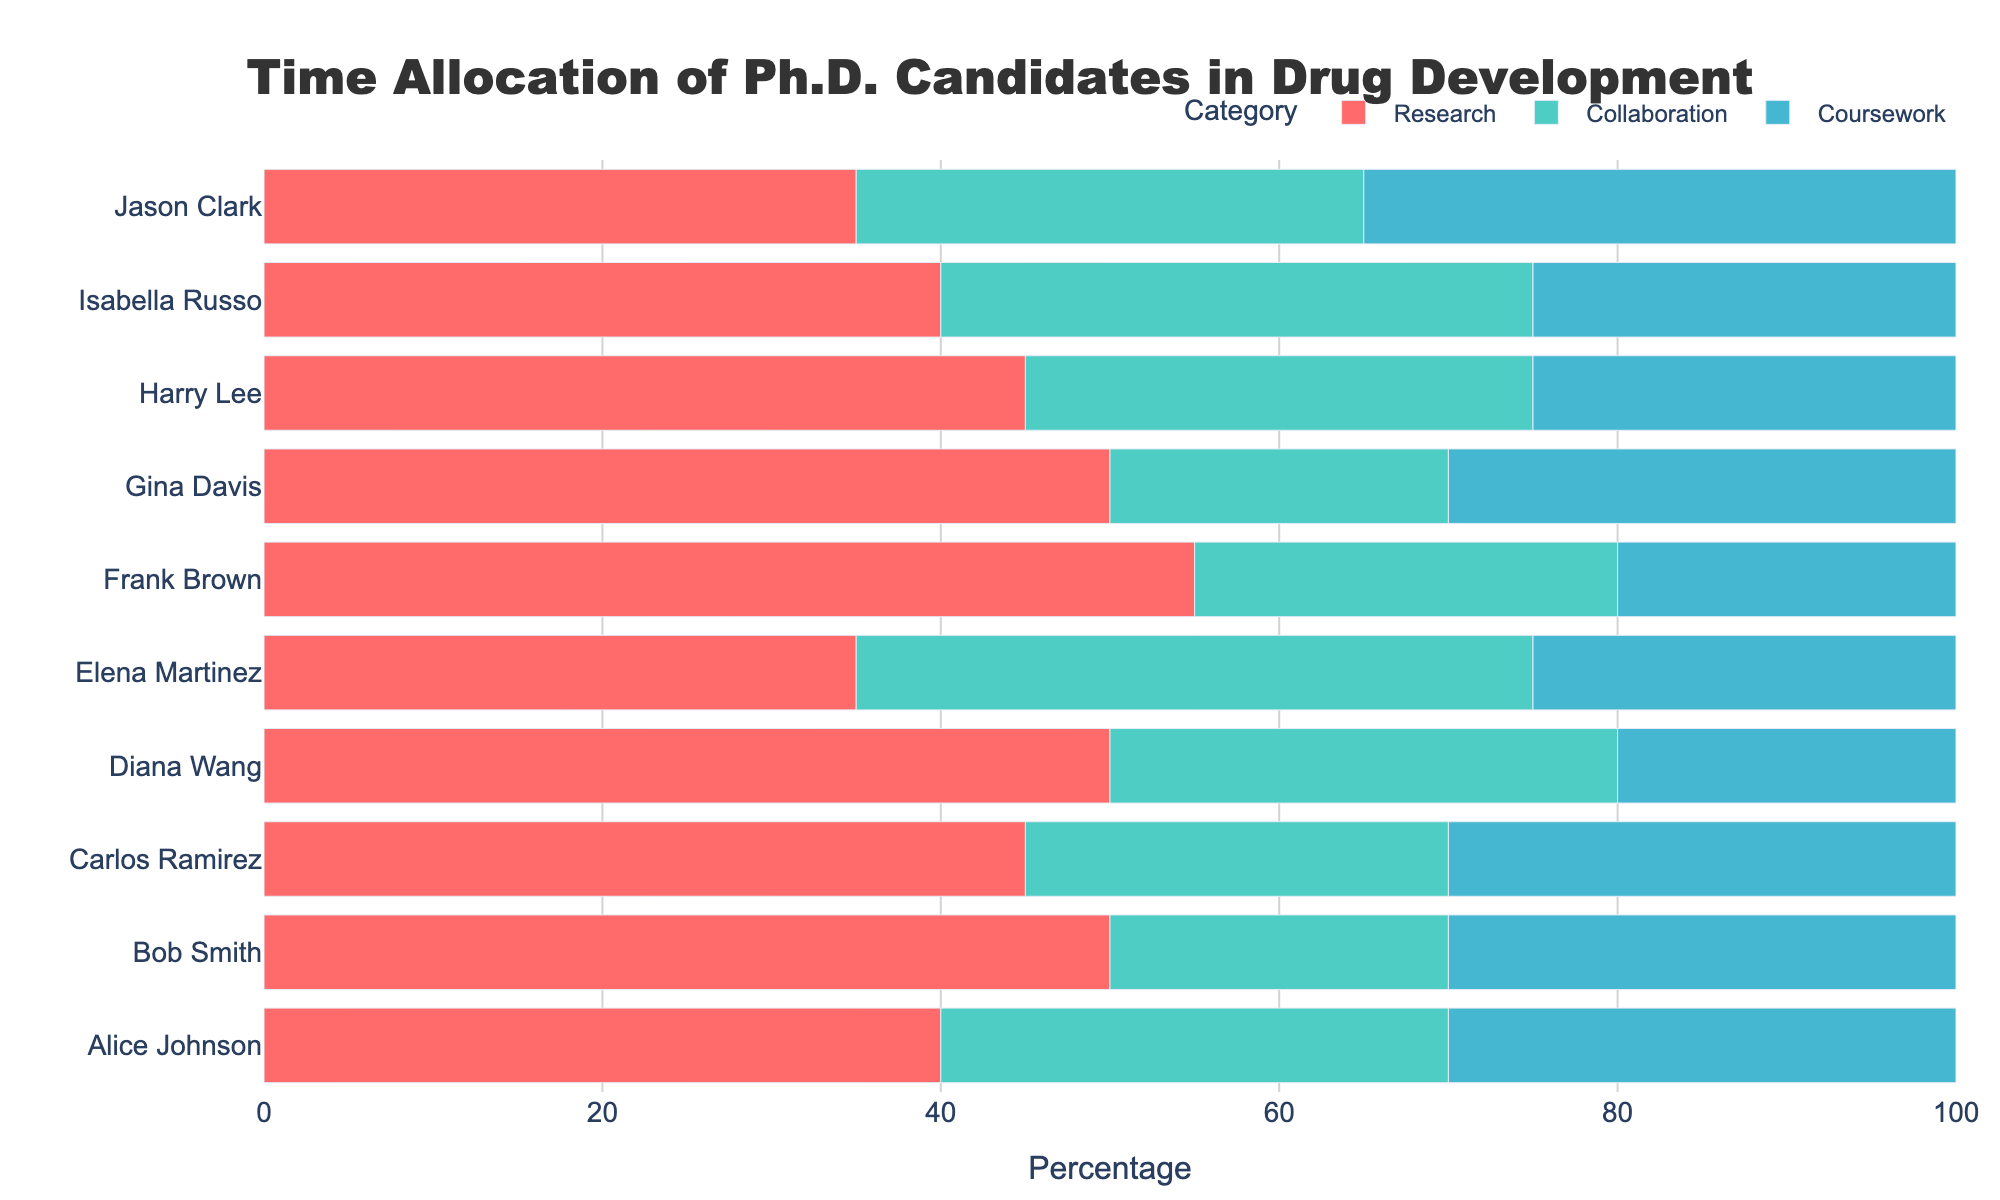What's the total time allocated to Coursework by all Ph.D. candidates combined? Sum up the percentages allocated to Coursework by each candidate: 30 + 30 + 30 + 20 + 25 + 20 + 30 + 25 + 25 + 35. The total is 270.
Answer: 270 Who spends more time on Collaboration, Elena Martinez or Alice Johnson? Compare the percentages: Elena Martinez allocates 40% to Collaboration, whereas Alice Johnson allocates 30%. Therefore, Elena Martinez spends more time.
Answer: Elena Martinez Which candidate allocates exactly half of their time to Research? Look for a candidate whose bar for Research is at 50%. Both Bob Smith and Diana Wang allocate 50% of their time to Research.
Answer: Bob Smith and Diana Wang How much more time does Frank Brown spend on Research compared to Coursework? Frank Brown spends 55% on Research and 20% on Coursework. The difference is 55% - 20% = 35%.
Answer: 35% Do any candidates allocate the same percentage of time to Collaboration and Coursework? If so, who? Check for candidates with equal bars for Collaboration and Coursework. Alice Johnson allocates 30% to both.
Answer: Alice Johnson What's the average time allocated to Research by all candidates? Sum the percentages for Research and divide by the number of candidates: (40 + 50 + 45 + 50 + 35 + 55 + 50 + 45 + 40 + 35) / 10 = 44.
Answer: 44 Who spends the least amount of time on Research? Look for the shortest bar in the Research category. Both Elena Martinez and Jason Clark allocate 35% to Research.
Answer: Elena Martinez and Jason Clark How does the time allocated to Research by Isabella Russo compare to that by Carlos Ramirez? Isabella Russo allocates 40% to Research, while Carlos Ramirez allocates 45%. Carlos Ramirez spends 5% more time on Research.
Answer: Carlos Ramirez spends 5% more time Of the candidates, who balances their time equally between Research, Collaboration, and Coursework? Check if any candidate has equal bars for all three categories. Alice Johnson balances her time with 40%, 30%, and 30%.
Answer: Alice Johnson 